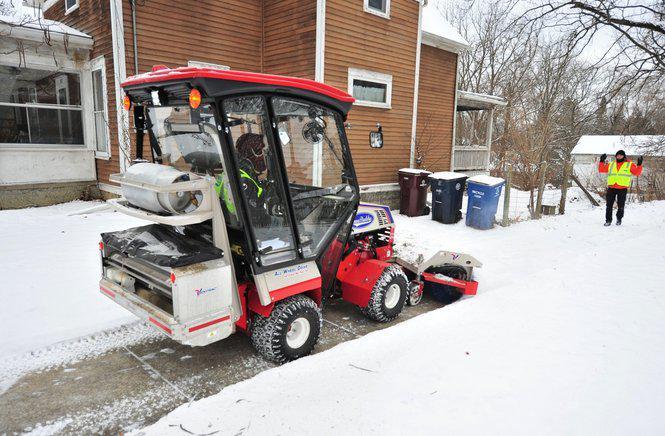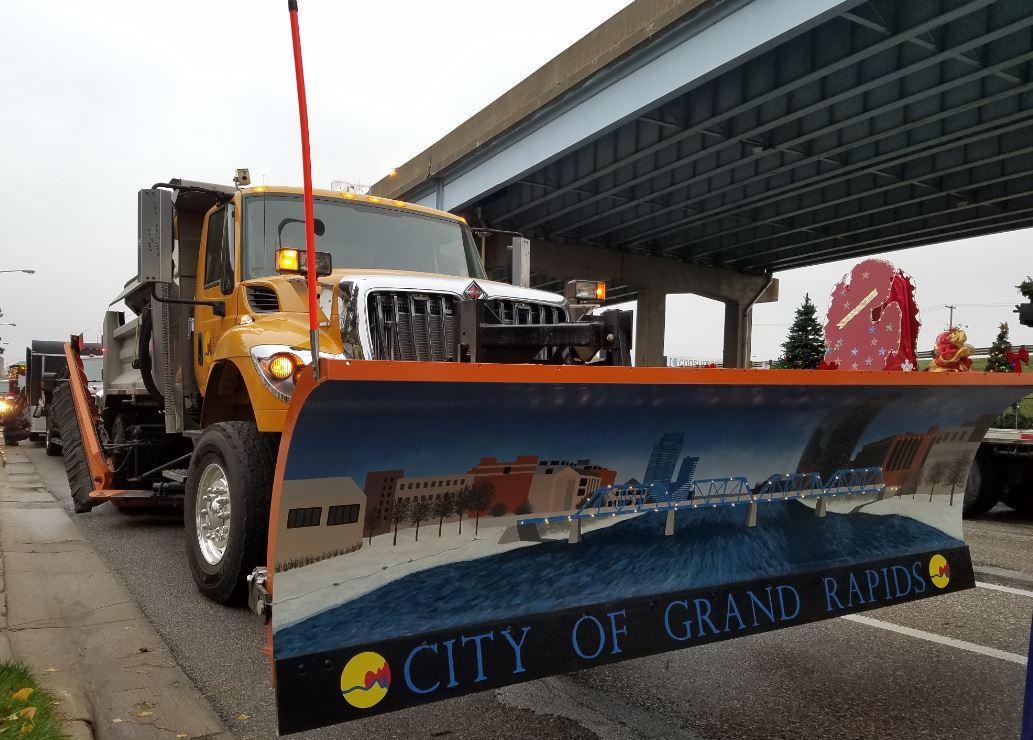The first image is the image on the left, the second image is the image on the right. For the images shown, is this caption "The left and right image contains the same number of white and yellow snow plows." true? Answer yes or no. No. The first image is the image on the left, the second image is the image on the right. Considering the images on both sides, is "Both plows are facing toward the bottom right and plowing snow." valid? Answer yes or no. No. 